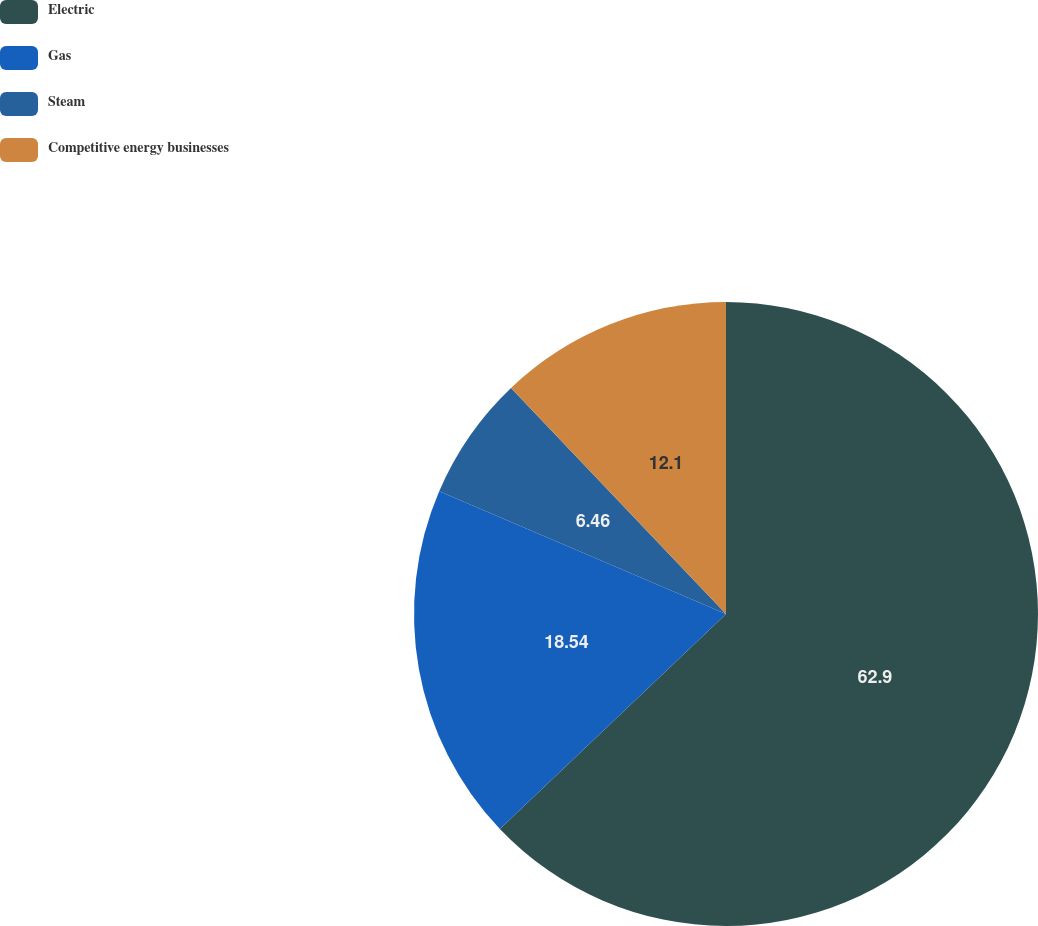Convert chart. <chart><loc_0><loc_0><loc_500><loc_500><pie_chart><fcel>Electric<fcel>Gas<fcel>Steam<fcel>Competitive energy businesses<nl><fcel>62.9%<fcel>18.54%<fcel>6.46%<fcel>12.1%<nl></chart> 